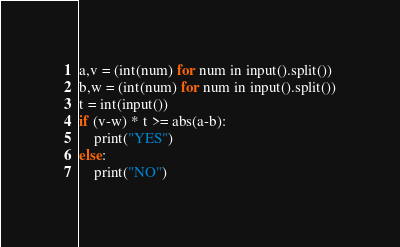Convert code to text. <code><loc_0><loc_0><loc_500><loc_500><_Python_>a,v = (int(num) for num in input().split())
b,w = (int(num) for num in input().split())
t = int(input())
if (v-w) * t >= abs(a-b):
    print("YES")
else:
    print("NO")</code> 